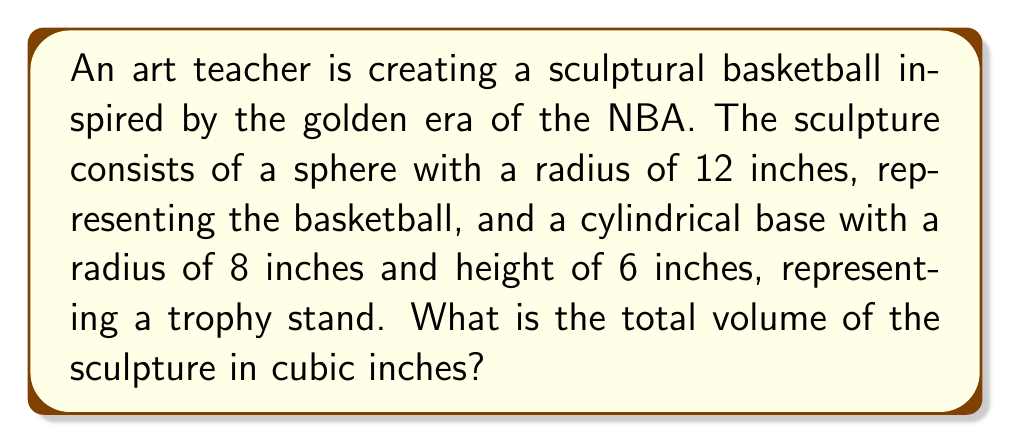Could you help me with this problem? To find the total volume of the sculpture, we need to calculate the volume of the sphere (basketball) and the volume of the cylinder (base) separately, then add them together.

1. Volume of the sphere (basketball):
   The formula for the volume of a sphere is $V_s = \frac{4}{3}\pi r^3$
   where $r$ is the radius of the sphere.
   
   $V_s = \frac{4}{3}\pi (12\text{ in})^3$
   $V_s = \frac{4}{3}\pi (1728\text{ in}^3)$
   $V_s = 2304\pi\text{ in}^3$

2. Volume of the cylinder (base):
   The formula for the volume of a cylinder is $V_c = \pi r^2 h$
   where $r$ is the radius of the base and $h$ is the height.
   
   $V_c = \pi (8\text{ in})^2 (6\text{ in})$
   $V_c = \pi (64\text{ in}^2) (6\text{ in})$
   $V_c = 384\pi\text{ in}^3$

3. Total volume:
   $V_{\text{total}} = V_s + V_c$
   $V_{\text{total}} = 2304\pi\text{ in}^3 + 384\pi\text{ in}^3$
   $V_{\text{total}} = 2688\pi\text{ in}^3$

To get the final numeric value, we can use $\pi \approx 3.14159$:

$V_{\text{total}} \approx 2688 \times 3.14159\text{ in}^3 \approx 8444.59\text{ in}^3$
Answer: $8444.59\text{ in}^3$ 